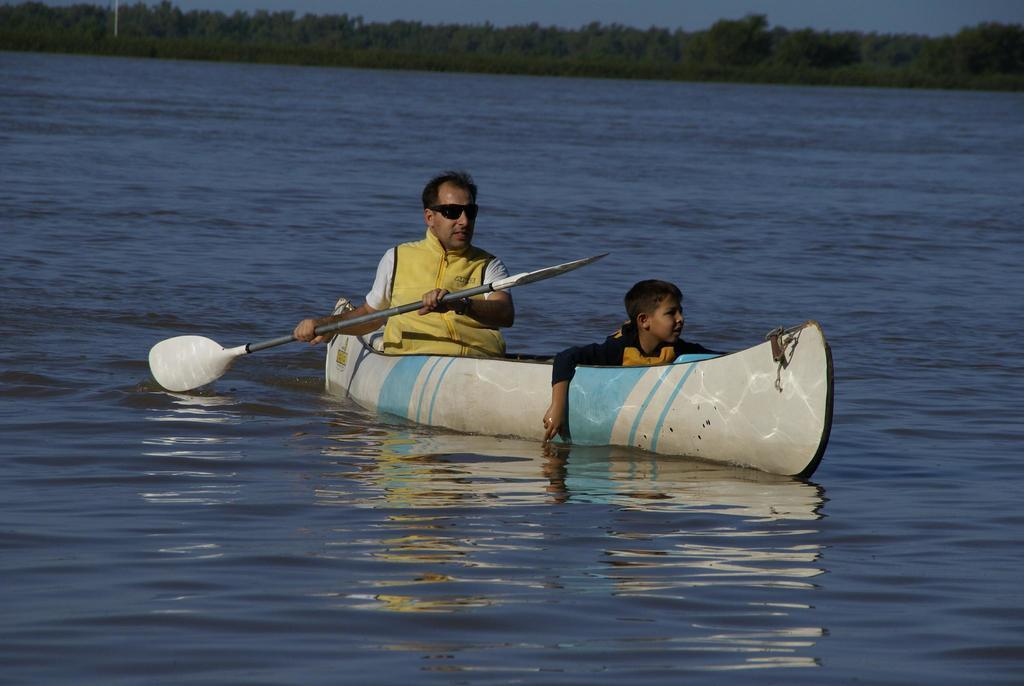In one or two sentences, can you explain what this image depicts? In this image, I can see a boy and a man holding a paddle are sitting on a boat, which is on the water. In the background, there are trees and the sky. 